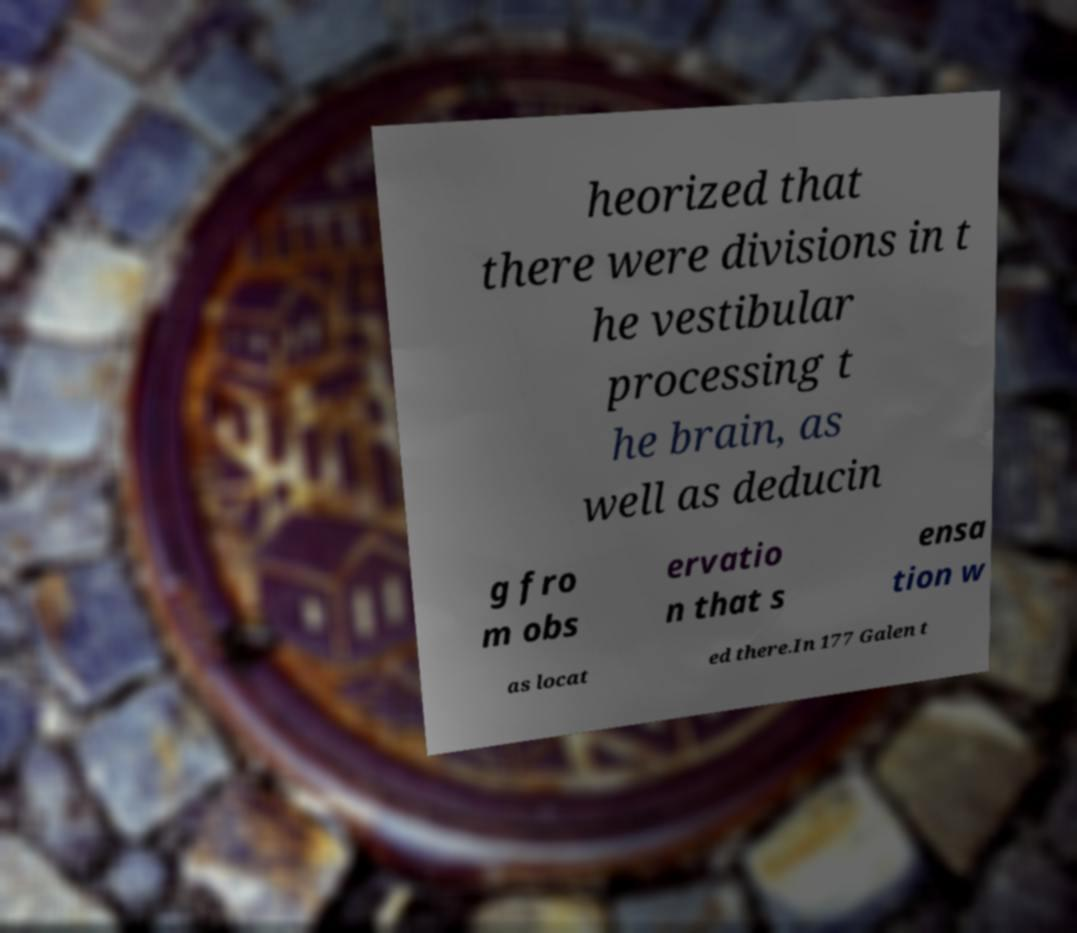What messages or text are displayed in this image? I need them in a readable, typed format. heorized that there were divisions in t he vestibular processing t he brain, as well as deducin g fro m obs ervatio n that s ensa tion w as locat ed there.In 177 Galen t 